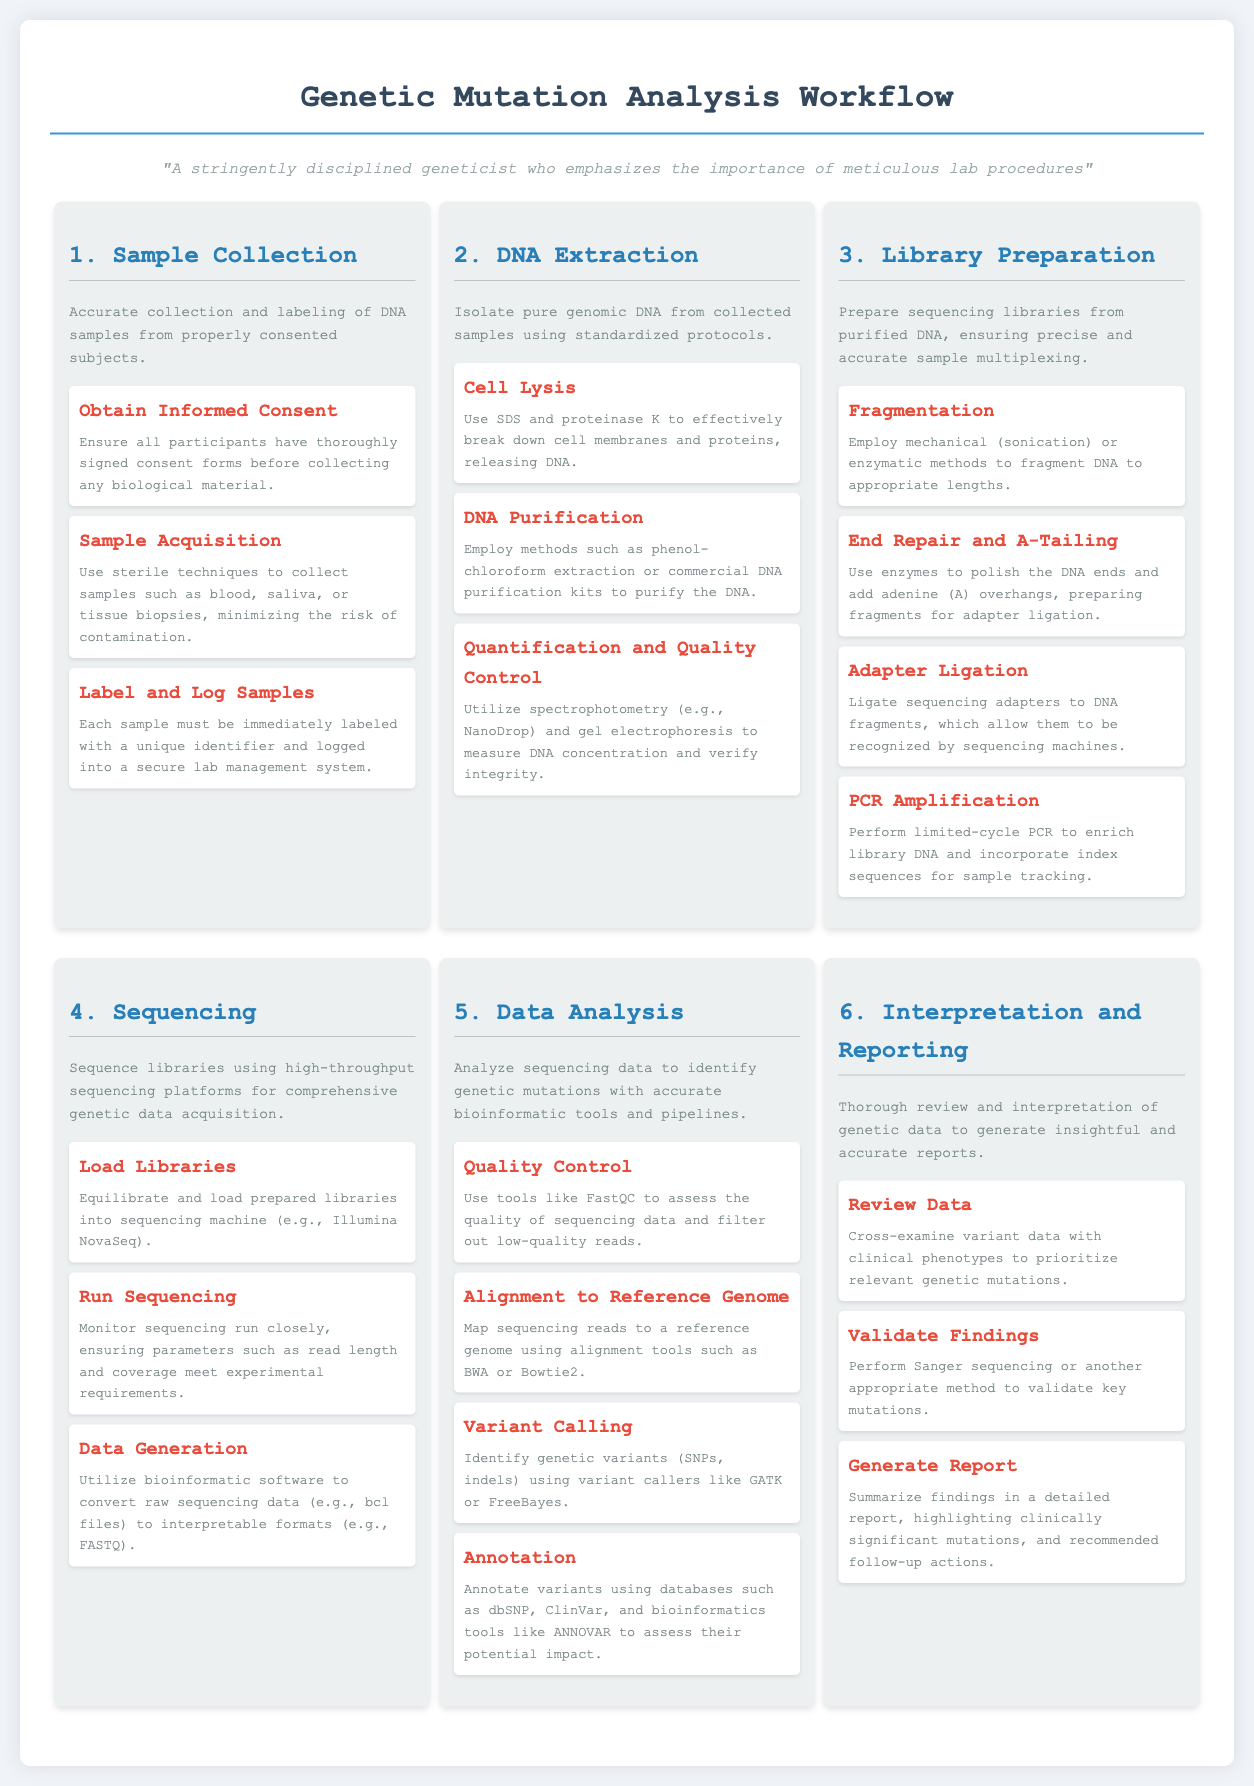What is the first stage of the workflow? The first stage of the workflow is explicitly titled "Sample Collection."
Answer: Sample Collection How many steps are involved in the DNA Extraction stage? The document lists three specific steps involved in the DNA Extraction stage.
Answer: 3 What technique is used for establishing informed consent? The document states that informed consent is obtained through signed consent forms.
Answer: Signed consent forms What bioinformatic tool is mentioned for quality control of sequencing data? FastQC is specifically mentioned as a tool for assessing the quality of sequencing data.
Answer: FastQC What is the purpose of adapter ligation in library preparation? Adapter ligation is indicated to allow DNA fragments to be recognized by sequencing machines.
Answer: Recognized by sequencing machines How many stages are there in total in the genetic mutation analysis workflow? The document outlines a total of six defined stages in the workflow.
Answer: 6 Which method is suggested for validating key mutations? The document advises performing Sanger sequencing or an appropriate method for validation.
Answer: Sanger sequencing What type of analysis is performed in the fifth stage? The fifth stage focuses on analyzing sequencing data to identify genetic mutations.
Answer: Genetic mutations Which genomic databases are recommended for variant annotation? The document mentions dbSNP and ClinVar for annotating variants.
Answer: dbSNP and ClinVar 